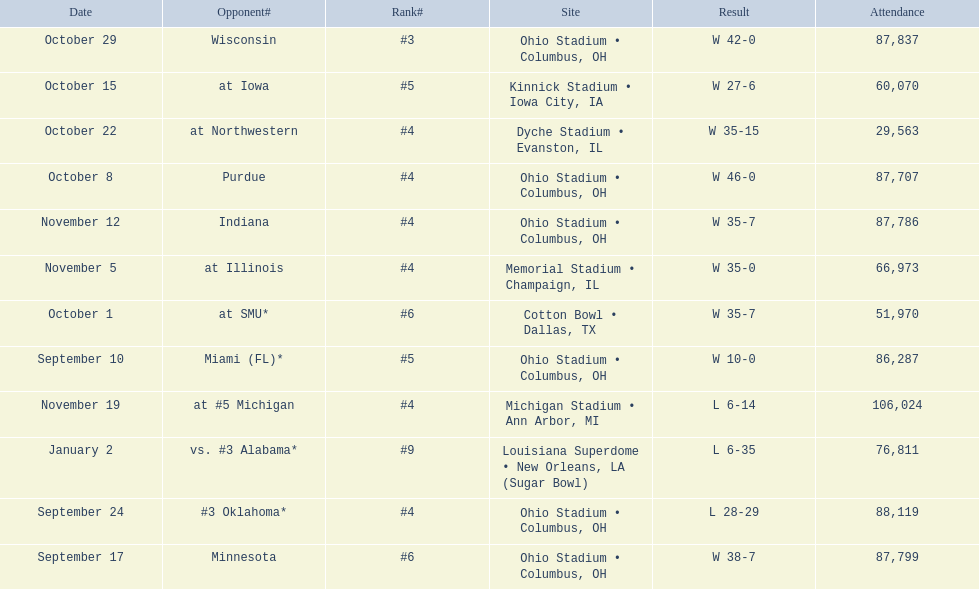How many dates are on the chart 12. 